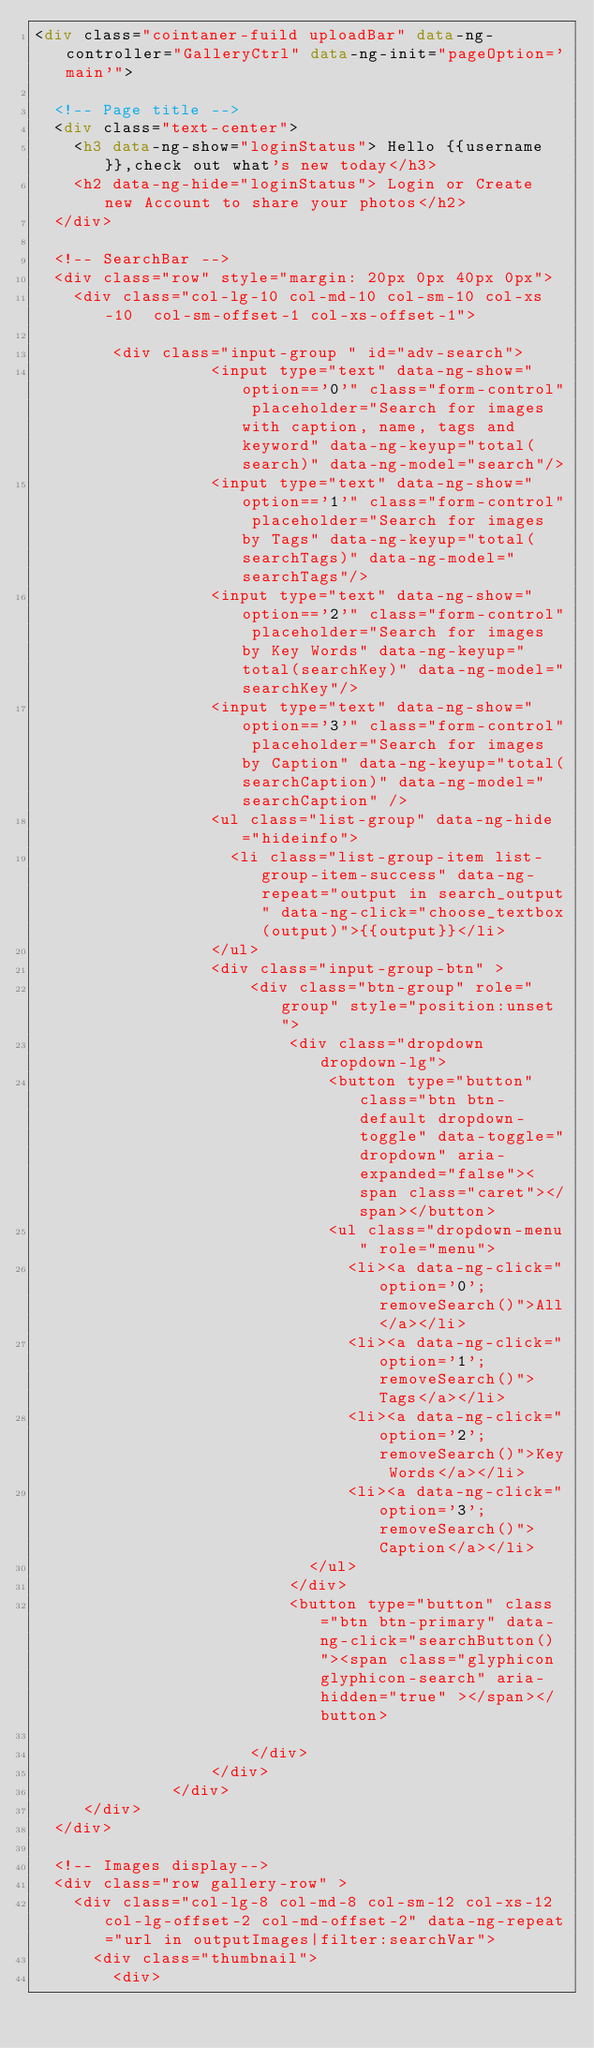Convert code to text. <code><loc_0><loc_0><loc_500><loc_500><_HTML_><div class="cointaner-fuild uploadBar" data-ng-controller="GalleryCtrl" data-ng-init="pageOption='main'">

  <!-- Page title -->
  <div class="text-center">
    <h3 data-ng-show="loginStatus"> Hello {{username}},check out what's new today</h3>
    <h2 data-ng-hide="loginStatus"> Login or Create new Account to share your photos</h2>
  </div>

  <!-- SearchBar -->
  <div class="row" style="margin: 20px 0px 40px 0px">
    <div class="col-lg-10 col-md-10 col-sm-10 col-xs-10  col-sm-offset-1 col-xs-offset-1">

        <div class="input-group " id="adv-search">
                  <input type="text" data-ng-show="option=='0'" class="form-control" placeholder="Search for images with caption, name, tags and keyword" data-ng-keyup="total(search)" data-ng-model="search"/>
                  <input type="text" data-ng-show="option=='1'" class="form-control" placeholder="Search for images by Tags" data-ng-keyup="total(searchTags)" data-ng-model="searchTags"/>
                  <input type="text" data-ng-show="option=='2'" class="form-control" placeholder="Search for images by Key Words" data-ng-keyup="total(searchKey)" data-ng-model="searchKey"/>
                  <input type="text" data-ng-show="option=='3'" class="form-control" placeholder="Search for images by Caption" data-ng-keyup="total(searchCaption)" data-ng-model="searchCaption" />
                  <ul class="list-group" data-ng-hide="hideinfo">
                    <li class="list-group-item list-group-item-success" data-ng-repeat="output in search_output" data-ng-click="choose_textbox(output)">{{output}}</li>
                  </ul>
                  <div class="input-group-btn" >
                      <div class="btn-group" role="group" style="position:unset">
                          <div class="dropdown dropdown-lg">
                              <button type="button" class="btn btn-default dropdown-toggle" data-toggle="dropdown" aria-expanded="false"><span class="caret"></span></button>
                              <ul class="dropdown-menu" role="menu">
                                <li><a data-ng-click="option='0';removeSearch()">All</a></li>
                                <li><a data-ng-click="option='1';removeSearch()">Tags</a></li>
                                <li><a data-ng-click="option='2';removeSearch()">Key Words</a></li>
                                <li><a data-ng-click="option='3';removeSearch()">Caption</a></li>
                            </ul>
                          </div>
                          <button type="button" class="btn btn-primary" data-ng-click="searchButton()"><span class="glyphicon glyphicon-search" aria-hidden="true" ></span></button>

                      </div>
                  </div>
              </div>
     </div>
  </div>

  <!-- Images display-->
  <div class="row gallery-row" >
    <div class="col-lg-8 col-md-8 col-sm-12 col-xs-12 col-lg-offset-2 col-md-offset-2" data-ng-repeat="url in outputImages|filter:searchVar">
      <div class="thumbnail">
        <div></code> 